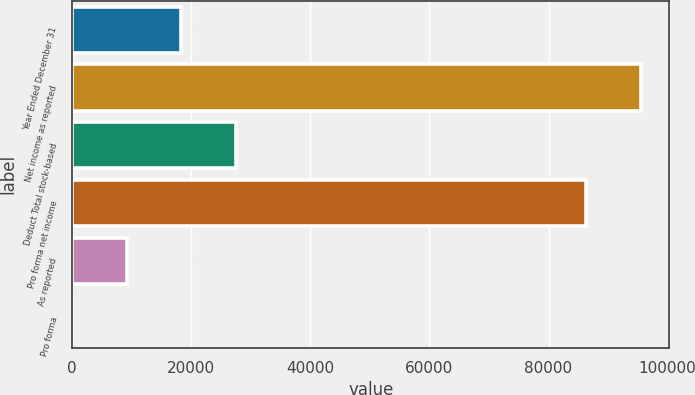<chart> <loc_0><loc_0><loc_500><loc_500><bar_chart><fcel>Year Ended December 31<fcel>Net income as reported<fcel>Deduct Total stock-based<fcel>Pro forma net income<fcel>As reported<fcel>Pro forma<nl><fcel>18340.7<fcel>95491.4<fcel>27510.1<fcel>86322<fcel>9171.25<fcel>1.83<nl></chart> 